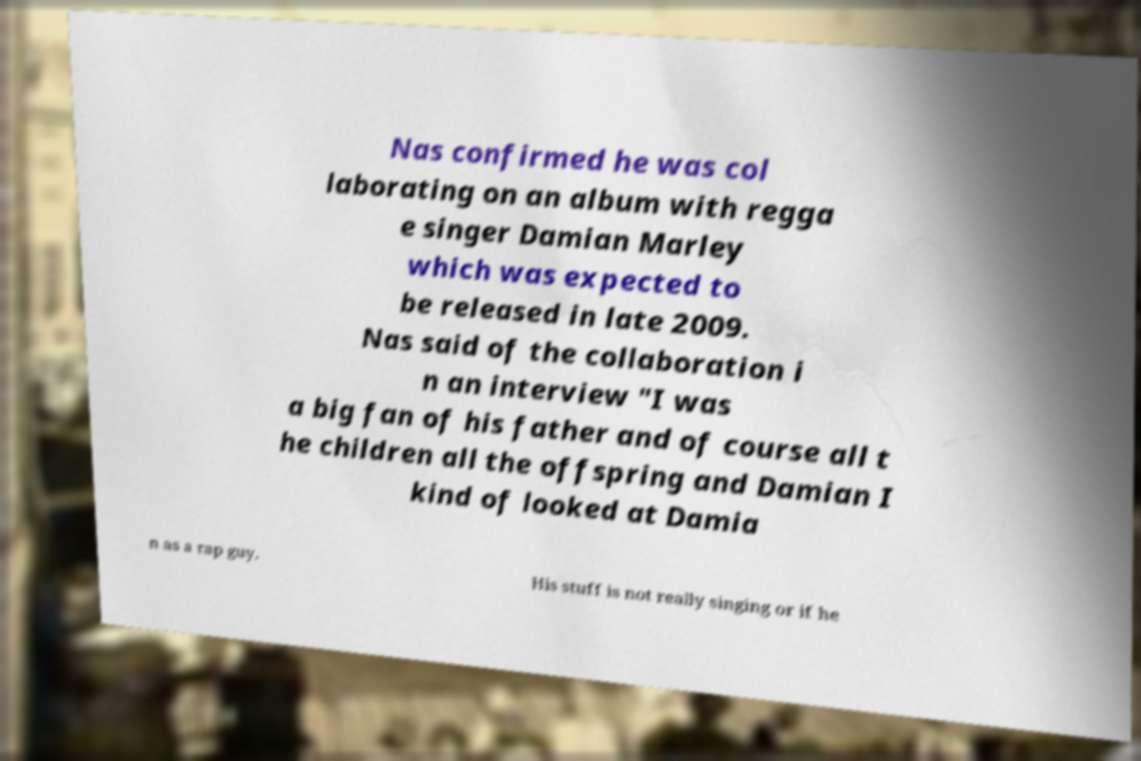Can you read and provide the text displayed in the image?This photo seems to have some interesting text. Can you extract and type it out for me? Nas confirmed he was col laborating on an album with regga e singer Damian Marley which was expected to be released in late 2009. Nas said of the collaboration i n an interview "I was a big fan of his father and of course all t he children all the offspring and Damian I kind of looked at Damia n as a rap guy. His stuff is not really singing or if he 